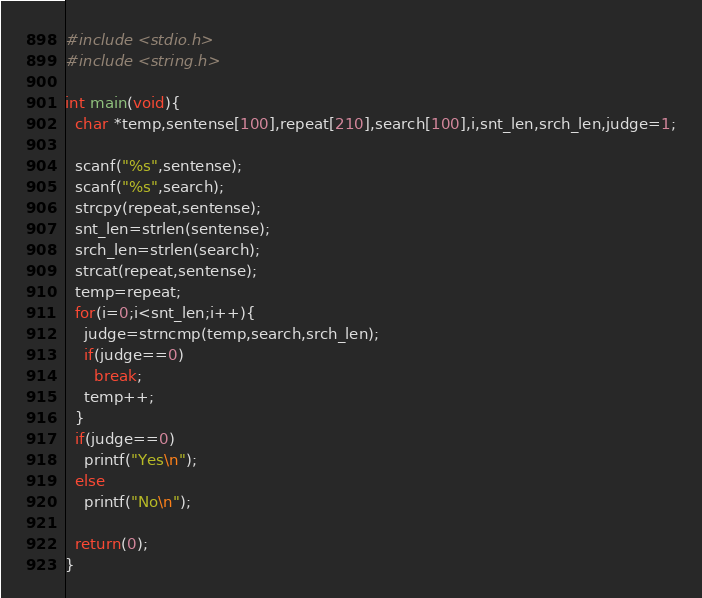Convert code to text. <code><loc_0><loc_0><loc_500><loc_500><_C_>#include <stdio.h>
#include <string.h>

int main(void){
  char *temp,sentense[100],repeat[210],search[100],i,snt_len,srch_len,judge=1;

  scanf("%s",sentense);
  scanf("%s",search);
  strcpy(repeat,sentense);
  snt_len=strlen(sentense);
  srch_len=strlen(search);
  strcat(repeat,sentense);
  temp=repeat;
  for(i=0;i<snt_len;i++){
    judge=strncmp(temp,search,srch_len);
    if(judge==0)
      break;
    temp++;
  }
  if(judge==0)
    printf("Yes\n");
  else
    printf("No\n");
  
  return(0);
}</code> 